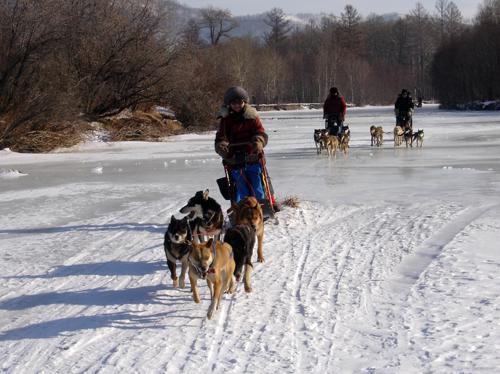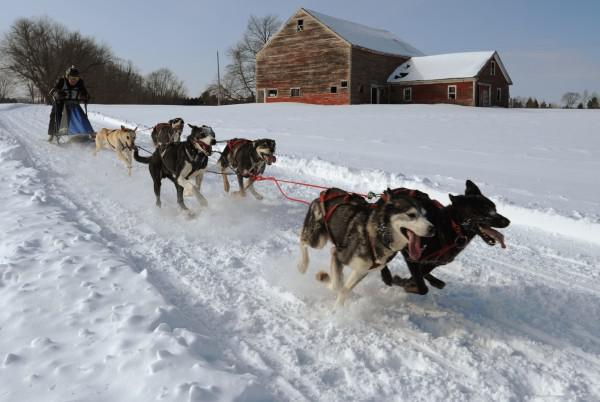The first image is the image on the left, the second image is the image on the right. Analyze the images presented: Is the assertion "In at least one image there are no more than four dogs dragging a single man with a black hat on the back of a sled." valid? Answer yes or no. No. The first image is the image on the left, the second image is the image on the right. Examine the images to the left and right. Is the description "The right image shows a dog team moving rightward across the snow past a type of housing shelter on the right." accurate? Answer yes or no. Yes. 